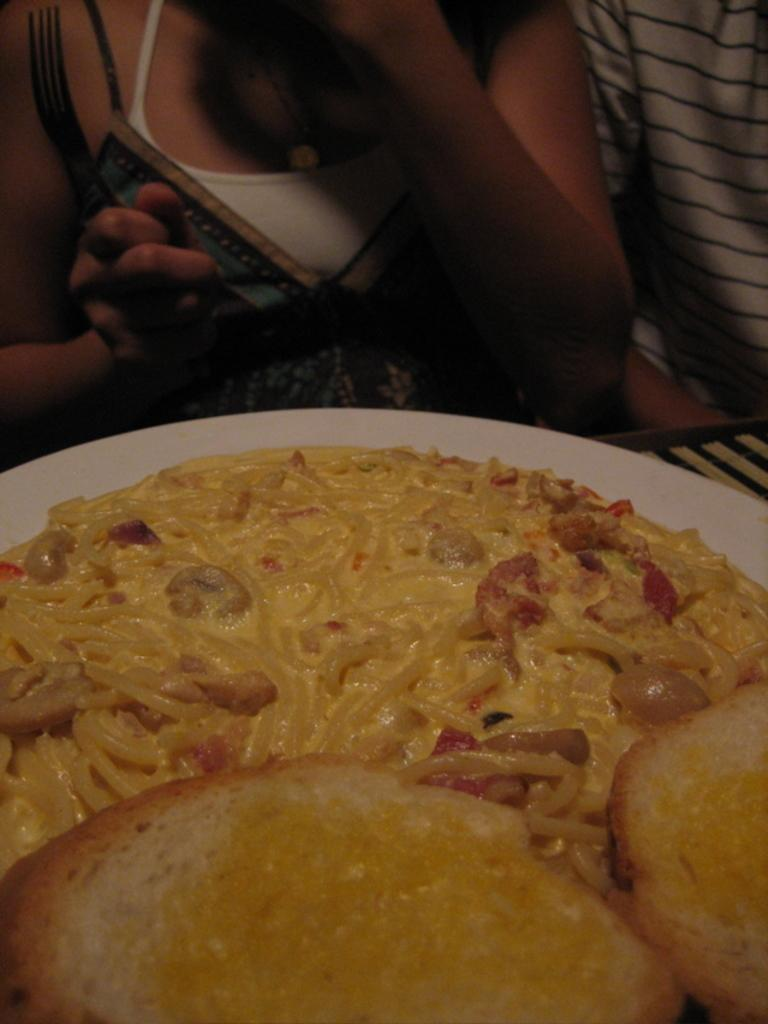What object is present on the table in the image? There is a plate in the image. What is on the plate? There is food on the plate. Can you describe the people behind the plate? There are two people behind the plate. What type of title is written on the plate in the image? There is no title written on the plate in the image. Can you see any apples on the plate or near the people in the image? There is no mention of apples in the image. What type of trousers are the people wearing in the image? The provided facts do not mention the type of trousers the people are wearing. 